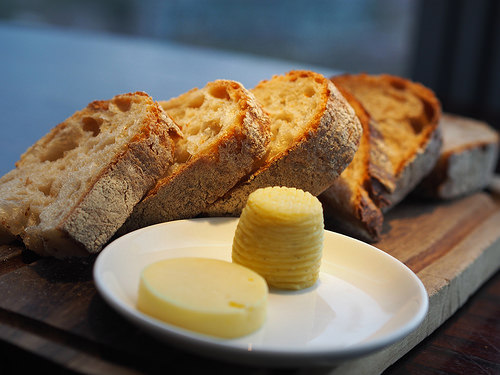<image>
Is the cheese on the bread? No. The cheese is not positioned on the bread. They may be near each other, but the cheese is not supported by or resting on top of the bread. Is the cake next to the plate? Yes. The cake is positioned adjacent to the plate, located nearby in the same general area. Where is the bread in relation to the cheese? Is it in front of the cheese? No. The bread is not in front of the cheese. The spatial positioning shows a different relationship between these objects. Where is the butter in relation to the breadboard? Is it above the breadboard? Yes. The butter is positioned above the breadboard in the vertical space, higher up in the scene. 